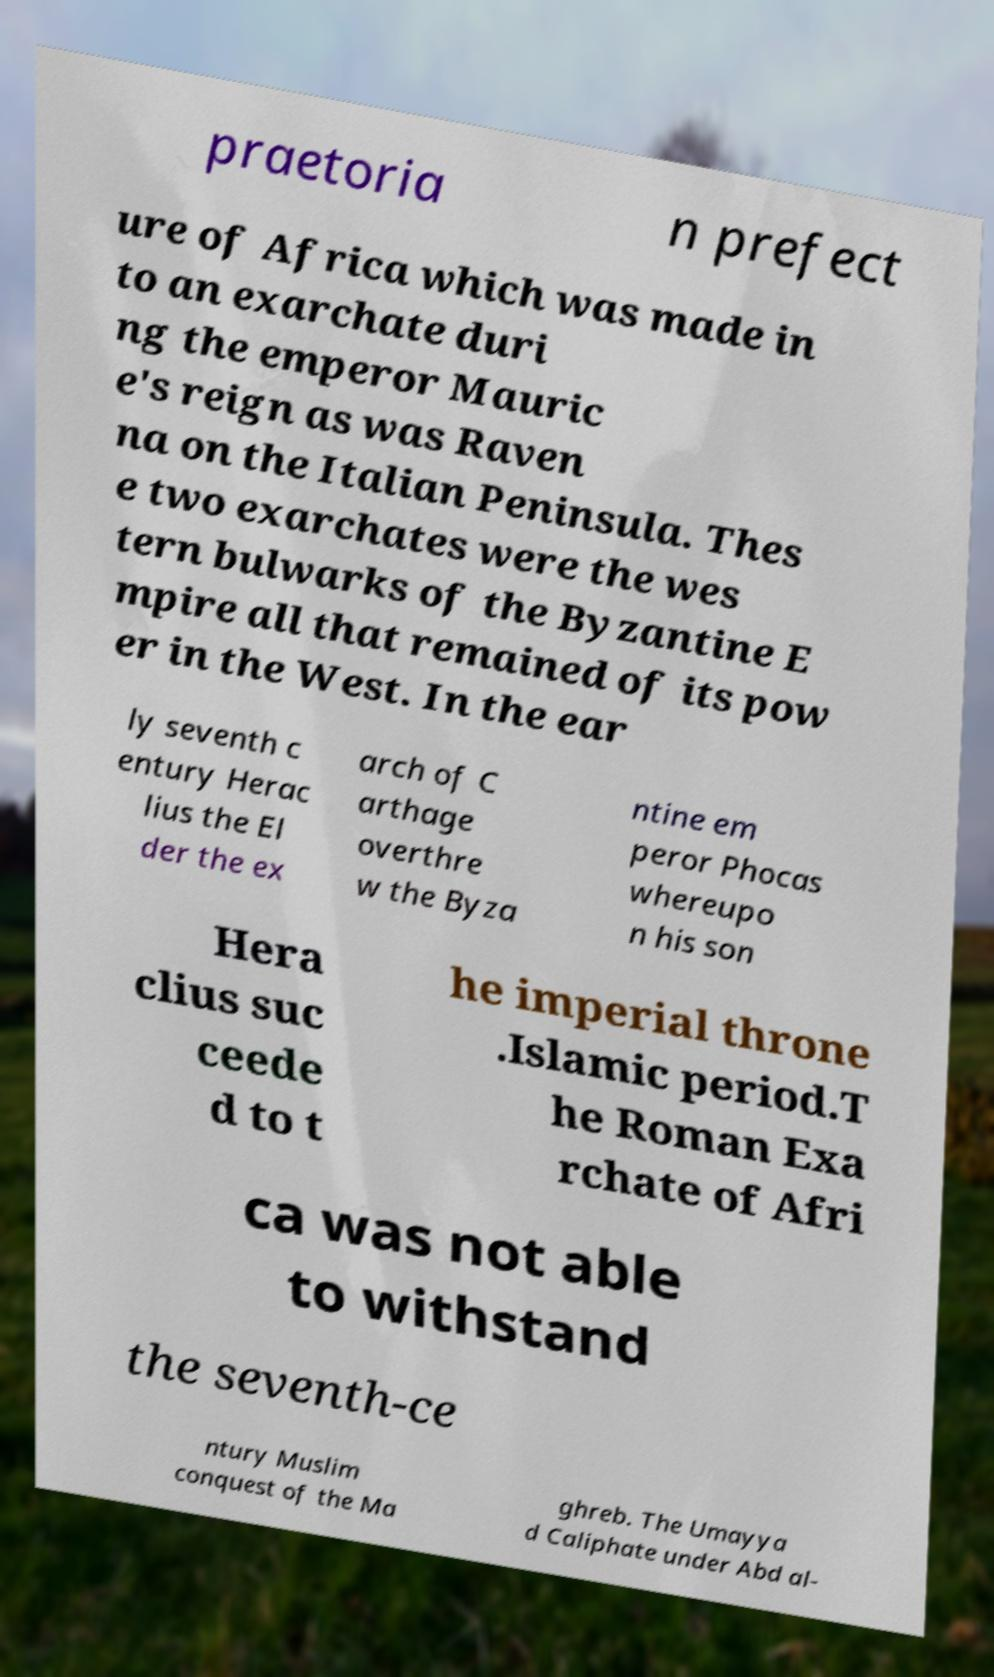Could you extract and type out the text from this image? praetoria n prefect ure of Africa which was made in to an exarchate duri ng the emperor Mauric e's reign as was Raven na on the Italian Peninsula. Thes e two exarchates were the wes tern bulwarks of the Byzantine E mpire all that remained of its pow er in the West. In the ear ly seventh c entury Herac lius the El der the ex arch of C arthage overthre w the Byza ntine em peror Phocas whereupo n his son Hera clius suc ceede d to t he imperial throne .Islamic period.T he Roman Exa rchate of Afri ca was not able to withstand the seventh-ce ntury Muslim conquest of the Ma ghreb. The Umayya d Caliphate under Abd al- 